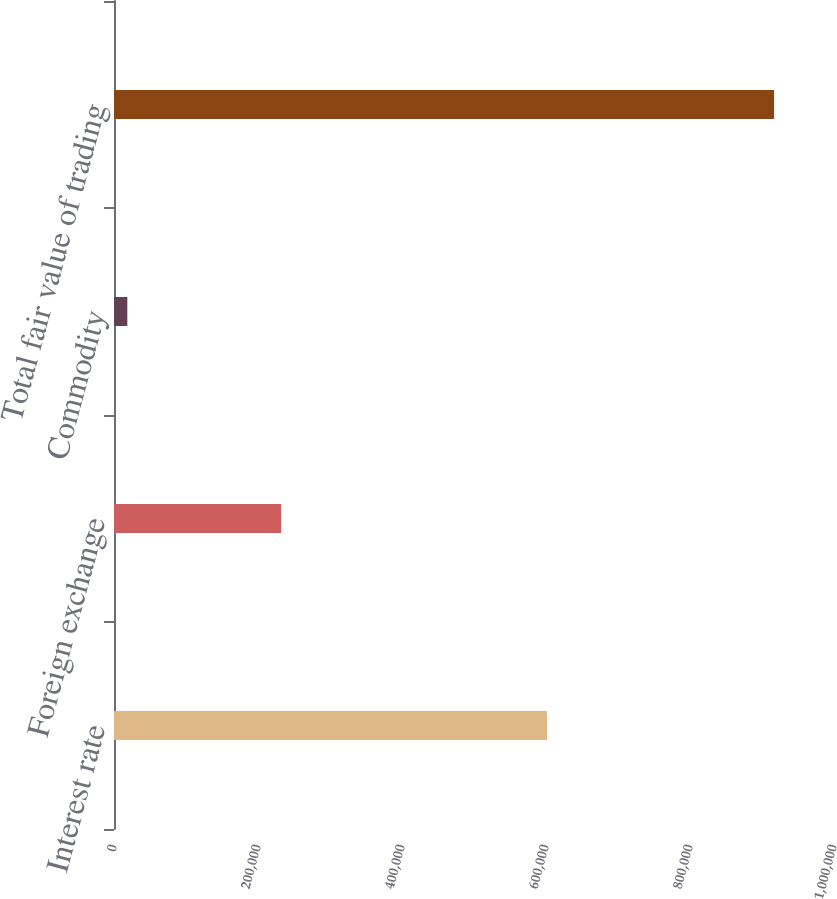Convert chart. <chart><loc_0><loc_0><loc_500><loc_500><bar_chart><fcel>Interest rate<fcel>Foreign exchange<fcel>Commodity<fcel>Total fair value of trading<nl><fcel>601557<fcel>232137<fcel>18505<fcel>916784<nl></chart> 